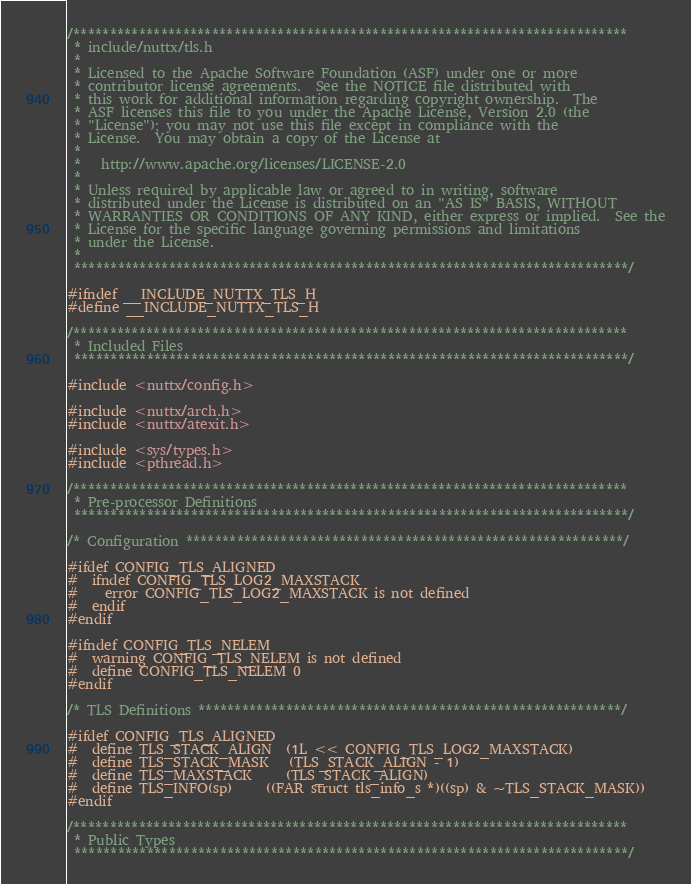<code> <loc_0><loc_0><loc_500><loc_500><_C_>/****************************************************************************
 * include/nuttx/tls.h
 *
 * Licensed to the Apache Software Foundation (ASF) under one or more
 * contributor license agreements.  See the NOTICE file distributed with
 * this work for additional information regarding copyright ownership.  The
 * ASF licenses this file to you under the Apache License, Version 2.0 (the
 * "License"); you may not use this file except in compliance with the
 * License.  You may obtain a copy of the License at
 *
 *   http://www.apache.org/licenses/LICENSE-2.0
 *
 * Unless required by applicable law or agreed to in writing, software
 * distributed under the License is distributed on an "AS IS" BASIS, WITHOUT
 * WARRANTIES OR CONDITIONS OF ANY KIND, either express or implied.  See the
 * License for the specific language governing permissions and limitations
 * under the License.
 *
 ****************************************************************************/

#ifndef __INCLUDE_NUTTX_TLS_H
#define __INCLUDE_NUTTX_TLS_H

/****************************************************************************
 * Included Files
 ****************************************************************************/

#include <nuttx/config.h>

#include <nuttx/arch.h>
#include <nuttx/atexit.h>

#include <sys/types.h>
#include <pthread.h>

/****************************************************************************
 * Pre-processor Definitions
 ****************************************************************************/

/* Configuration ************************************************************/

#ifdef CONFIG_TLS_ALIGNED
#  ifndef CONFIG_TLS_LOG2_MAXSTACK
#    error CONFIG_TLS_LOG2_MAXSTACK is not defined
#  endif
#endif

#ifndef CONFIG_TLS_NELEM
#  warning CONFIG_TLS_NELEM is not defined
#  define CONFIG_TLS_NELEM 0
#endif

/* TLS Definitions **********************************************************/

#ifdef CONFIG_TLS_ALIGNED
#  define TLS_STACK_ALIGN  (1L << CONFIG_TLS_LOG2_MAXSTACK)
#  define TLS_STACK_MASK   (TLS_STACK_ALIGN - 1)
#  define TLS_MAXSTACK     (TLS_STACK_ALIGN)
#  define TLS_INFO(sp)     ((FAR struct tls_info_s *)((sp) & ~TLS_STACK_MASK))
#endif

/****************************************************************************
 * Public Types
 ****************************************************************************/
</code> 